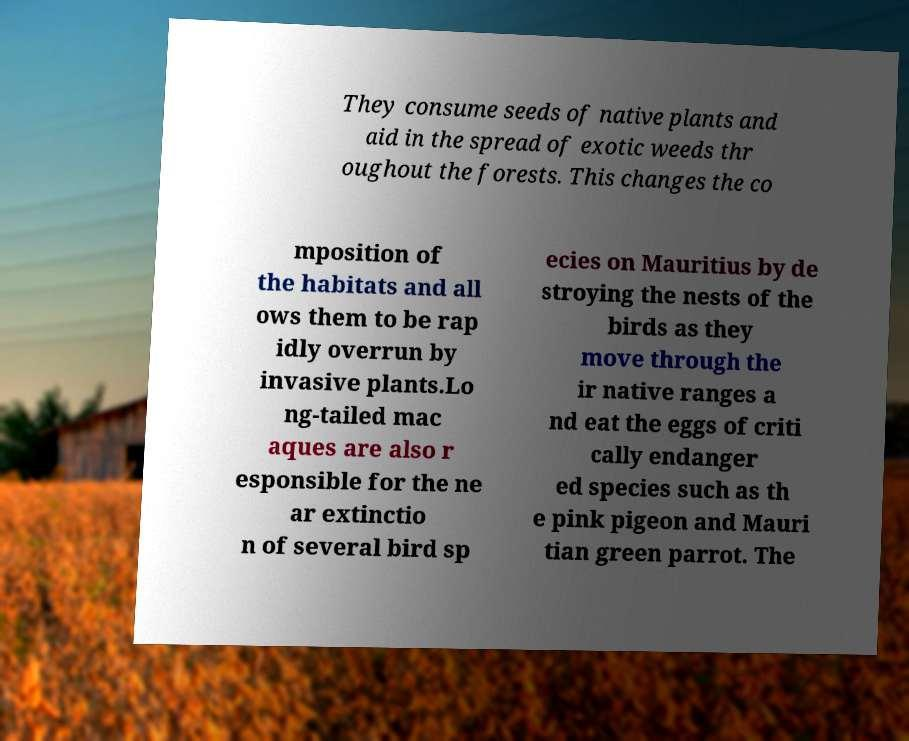Could you extract and type out the text from this image? They consume seeds of native plants and aid in the spread of exotic weeds thr oughout the forests. This changes the co mposition of the habitats and all ows them to be rap idly overrun by invasive plants.Lo ng-tailed mac aques are also r esponsible for the ne ar extinctio n of several bird sp ecies on Mauritius by de stroying the nests of the birds as they move through the ir native ranges a nd eat the eggs of criti cally endanger ed species such as th e pink pigeon and Mauri tian green parrot. The 